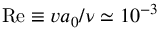<formula> <loc_0><loc_0><loc_500><loc_500>R e \equiv v a _ { 0 } / \nu \simeq 1 0 ^ { - 3 }</formula> 